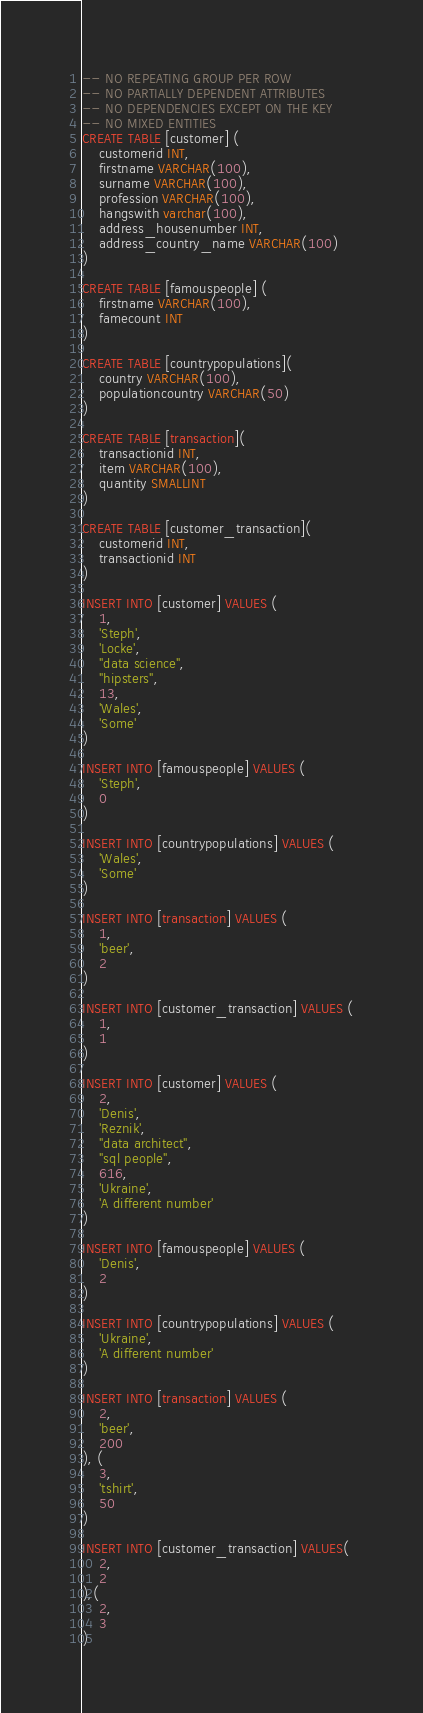<code> <loc_0><loc_0><loc_500><loc_500><_SQL_>-- NO REPEATING GROUP PER ROW
-- NO PARTIALLY DEPENDENT ATTRIBUTES
-- NO DEPENDENCIES EXCEPT ON THE KEY
-- NO MIXED ENTITIES
CREATE TABLE [customer] (
    customerid INT,  
    firstname VARCHAR(100),
    surname VARCHAR(100),
    profession VARCHAR(100),
    hangswith varchar(100),
    address_housenumber INT,
    address_country_name VARCHAR(100)
)

CREATE TABLE [famouspeople] (
    firstname VARCHAR(100),
    famecount INT
)

CREATE TABLE [countrypopulations](
    country VARCHAR(100),
    populationcountry VARCHAR(50)
)

CREATE TABLE [transaction](
    transactionid INT,
    item VARCHAR(100),
    quantity SMALLINT
)

CREATE TABLE [customer_transaction](
    customerid INT,
    transactionid INT
)

INSERT INTO [customer] VALUES (
    1, 
    'Steph',
    'Locke',
    "data science",
    "hipsters",
    13,
    'Wales',
    'Some'
)

INSERT INTO [famouspeople] VALUES (
    'Steph',
    0
)

INSERT INTO [countrypopulations] VALUES (
    'Wales',
    'Some'
)

INSERT INTO [transaction] VALUES (
    1,
    'beer',
    2
)

INSERT INTO [customer_transaction] VALUES (
    1,
    1
)

INSERT INTO [customer] VALUES ( 
    2,
    'Denis',
    'Reznik',
    "data architect",
    "sql people",
    616,
    'Ukraine',
    'A different number'
)

INSERT INTO [famouspeople] VALUES (
    'Denis',
    2
)

INSERT INTO [countrypopulations] VALUES (
    'Ukraine',
    'A different number'
)

INSERT INTO [transaction] VALUES (
    2,
    'beer',
    200
), (
    3,
    'tshirt',
    50
)

INSERT INTO [customer_transaction] VALUES(
    2,
    2
),(
    2,
    3
)</code> 